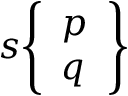<formula> <loc_0><loc_0><loc_500><loc_500>s { \left \{ \begin{array} { l } { p } \\ { q } \end{array} \right \} }</formula> 